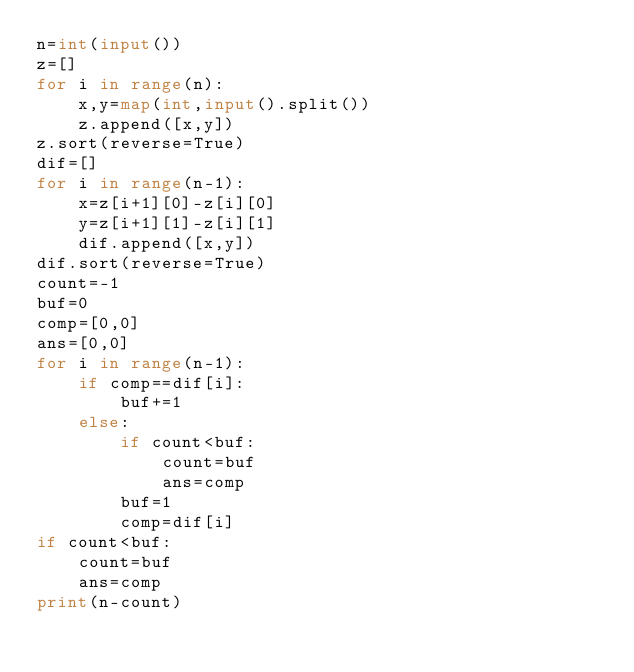Convert code to text. <code><loc_0><loc_0><loc_500><loc_500><_Python_>n=int(input())
z=[]
for i in range(n):
    x,y=map(int,input().split())
    z.append([x,y])
z.sort(reverse=True)
dif=[]
for i in range(n-1):
    x=z[i+1][0]-z[i][0]
    y=z[i+1][1]-z[i][1]
    dif.append([x,y])
dif.sort(reverse=True)
count=-1
buf=0
comp=[0,0]
ans=[0,0]
for i in range(n-1):
    if comp==dif[i]:
        buf+=1
    else:
        if count<buf:
            count=buf
            ans=comp
        buf=1
        comp=dif[i]
if count<buf:
    count=buf
    ans=comp
print(n-count)</code> 